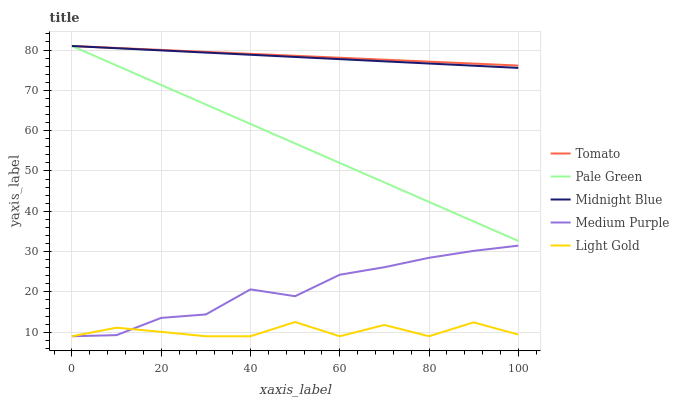Does Light Gold have the minimum area under the curve?
Answer yes or no. Yes. Does Tomato have the maximum area under the curve?
Answer yes or no. Yes. Does Medium Purple have the minimum area under the curve?
Answer yes or no. No. Does Medium Purple have the maximum area under the curve?
Answer yes or no. No. Is Midnight Blue the smoothest?
Answer yes or no. Yes. Is Light Gold the roughest?
Answer yes or no. Yes. Is Medium Purple the smoothest?
Answer yes or no. No. Is Medium Purple the roughest?
Answer yes or no. No. Does Medium Purple have the lowest value?
Answer yes or no. Yes. Does Pale Green have the lowest value?
Answer yes or no. No. Does Midnight Blue have the highest value?
Answer yes or no. Yes. Does Medium Purple have the highest value?
Answer yes or no. No. Is Light Gold less than Tomato?
Answer yes or no. Yes. Is Pale Green greater than Medium Purple?
Answer yes or no. Yes. Does Midnight Blue intersect Pale Green?
Answer yes or no. Yes. Is Midnight Blue less than Pale Green?
Answer yes or no. No. Is Midnight Blue greater than Pale Green?
Answer yes or no. No. Does Light Gold intersect Tomato?
Answer yes or no. No. 